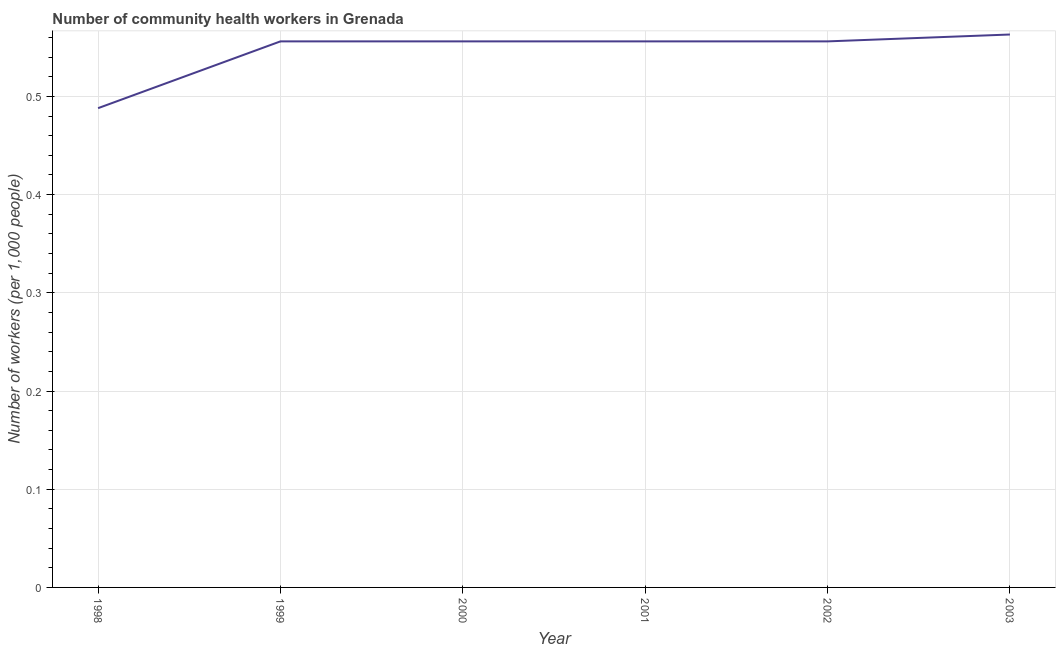What is the number of community health workers in 2001?
Offer a terse response. 0.56. Across all years, what is the maximum number of community health workers?
Offer a terse response. 0.56. Across all years, what is the minimum number of community health workers?
Your answer should be compact. 0.49. What is the sum of the number of community health workers?
Ensure brevity in your answer.  3.28. What is the difference between the number of community health workers in 1998 and 2000?
Offer a very short reply. -0.07. What is the average number of community health workers per year?
Offer a very short reply. 0.55. What is the median number of community health workers?
Offer a very short reply. 0.56. In how many years, is the number of community health workers greater than 0.4 ?
Give a very brief answer. 6. Do a majority of the years between 1999 and 2003 (inclusive) have number of community health workers greater than 0.54 ?
Offer a very short reply. Yes. What is the ratio of the number of community health workers in 2002 to that in 2003?
Your answer should be compact. 0.99. What is the difference between the highest and the second highest number of community health workers?
Your answer should be compact. 0.01. What is the difference between the highest and the lowest number of community health workers?
Provide a succinct answer. 0.07. How many lines are there?
Keep it short and to the point. 1. What is the difference between two consecutive major ticks on the Y-axis?
Your answer should be very brief. 0.1. Does the graph contain grids?
Offer a terse response. Yes. What is the title of the graph?
Ensure brevity in your answer.  Number of community health workers in Grenada. What is the label or title of the Y-axis?
Provide a short and direct response. Number of workers (per 1,0 people). What is the Number of workers (per 1,000 people) of 1998?
Provide a short and direct response. 0.49. What is the Number of workers (per 1,000 people) in 1999?
Your answer should be very brief. 0.56. What is the Number of workers (per 1,000 people) in 2000?
Your answer should be compact. 0.56. What is the Number of workers (per 1,000 people) of 2001?
Ensure brevity in your answer.  0.56. What is the Number of workers (per 1,000 people) in 2002?
Ensure brevity in your answer.  0.56. What is the Number of workers (per 1,000 people) in 2003?
Offer a very short reply. 0.56. What is the difference between the Number of workers (per 1,000 people) in 1998 and 1999?
Your answer should be very brief. -0.07. What is the difference between the Number of workers (per 1,000 people) in 1998 and 2000?
Your response must be concise. -0.07. What is the difference between the Number of workers (per 1,000 people) in 1998 and 2001?
Your answer should be very brief. -0.07. What is the difference between the Number of workers (per 1,000 people) in 1998 and 2002?
Offer a very short reply. -0.07. What is the difference between the Number of workers (per 1,000 people) in 1998 and 2003?
Your response must be concise. -0.07. What is the difference between the Number of workers (per 1,000 people) in 1999 and 2000?
Provide a succinct answer. 0. What is the difference between the Number of workers (per 1,000 people) in 1999 and 2003?
Your answer should be compact. -0.01. What is the difference between the Number of workers (per 1,000 people) in 2000 and 2002?
Provide a short and direct response. 0. What is the difference between the Number of workers (per 1,000 people) in 2000 and 2003?
Your answer should be very brief. -0.01. What is the difference between the Number of workers (per 1,000 people) in 2001 and 2003?
Keep it short and to the point. -0.01. What is the difference between the Number of workers (per 1,000 people) in 2002 and 2003?
Give a very brief answer. -0.01. What is the ratio of the Number of workers (per 1,000 people) in 1998 to that in 1999?
Your answer should be very brief. 0.88. What is the ratio of the Number of workers (per 1,000 people) in 1998 to that in 2000?
Ensure brevity in your answer.  0.88. What is the ratio of the Number of workers (per 1,000 people) in 1998 to that in 2001?
Your answer should be compact. 0.88. What is the ratio of the Number of workers (per 1,000 people) in 1998 to that in 2002?
Give a very brief answer. 0.88. What is the ratio of the Number of workers (per 1,000 people) in 1998 to that in 2003?
Your answer should be compact. 0.87. What is the ratio of the Number of workers (per 1,000 people) in 1999 to that in 2000?
Offer a terse response. 1. What is the ratio of the Number of workers (per 1,000 people) in 1999 to that in 2002?
Keep it short and to the point. 1. What is the ratio of the Number of workers (per 1,000 people) in 2000 to that in 2003?
Provide a short and direct response. 0.99. What is the ratio of the Number of workers (per 1,000 people) in 2001 to that in 2002?
Your answer should be very brief. 1. What is the ratio of the Number of workers (per 1,000 people) in 2001 to that in 2003?
Provide a short and direct response. 0.99. 